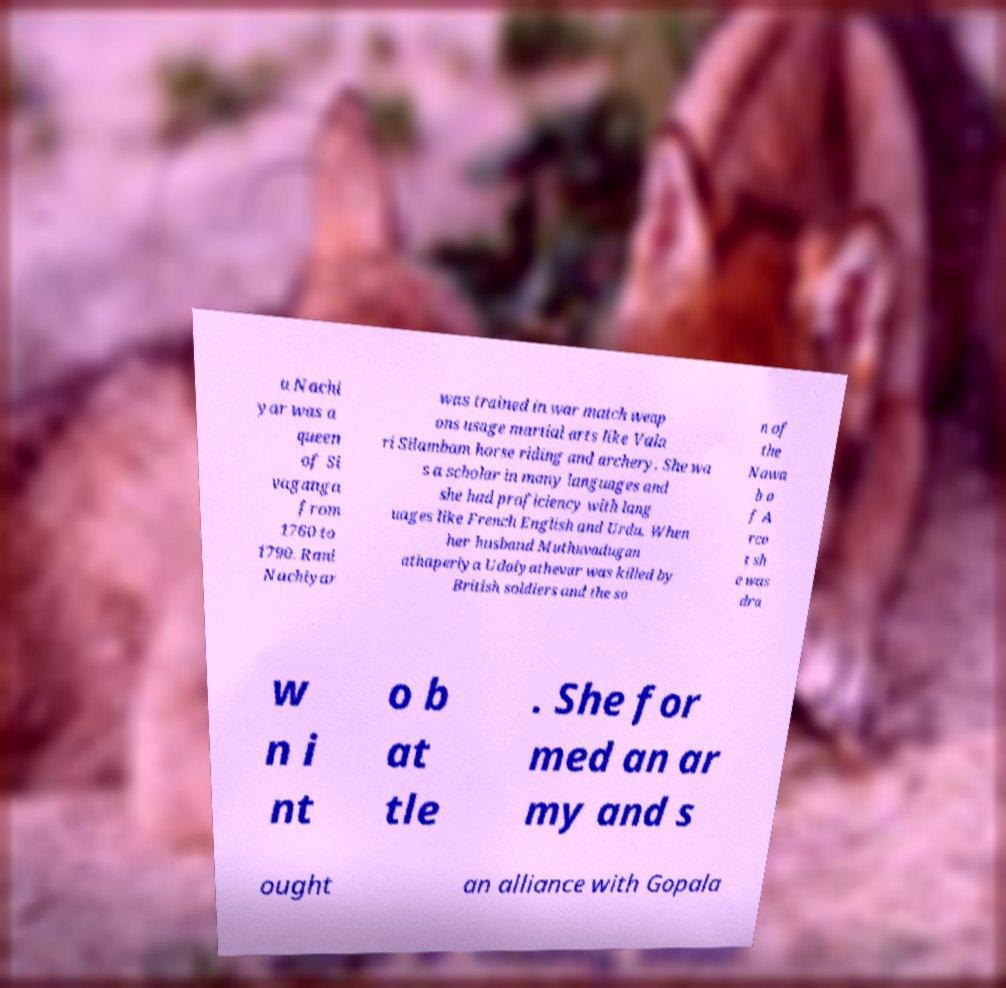Please read and relay the text visible in this image. What does it say? u Nachi yar was a queen of Si vaganga from 1760 to 1790. Rani Nachiyar was trained in war match weap ons usage martial arts like Vala ri Silambam horse riding and archery. She wa s a scholar in many languages and she had proficiency with lang uages like French English and Urdu. When her husband Muthuvadugan athaperiya Udaiyathevar was killed by British soldiers and the so n of the Nawa b o f A rco t sh e was dra w n i nt o b at tle . She for med an ar my and s ought an alliance with Gopala 